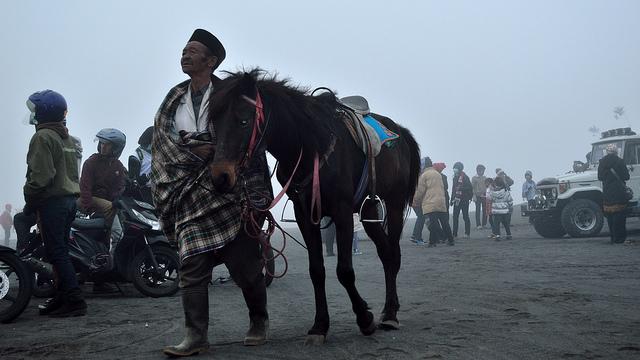Is this a calming photo?
Give a very brief answer. No. How many horses are in this picture?
Write a very short answer. 1. What is the fastest mode of transportation pictured here?
Concise answer only. Motorcycle. Is this  a color photo?
Give a very brief answer. Yes. Does this look like a place where you'd expect to find a horse?
Be succinct. No. What animal is this?
Give a very brief answer. Horse. How many horses in this photo?
Quick response, please. 1. What are the horses standing on?
Short answer required. Dirt. The plaid design is part of what?
Answer briefly. Blanket. What color is the man's hat?
Be succinct. Black. What are the men riding?
Answer briefly. Motorcycles. From the quality of the shadows, does the sky appear to be clear or overcast (or cloudy)?
Write a very short answer. Overcast. What color are the people's hats?
Write a very short answer. Black. Is the horse running?
Give a very brief answer. No. How many blue cars are in the background?
Write a very short answer. 0. What color are the lead walker's shoelaces?
Give a very brief answer. None. Is there any grass?
Give a very brief answer. No. What color is the photo?
Write a very short answer. Color. How many people ride bikes?
Short answer required. 2. What color is the taller boys shirt?
Be succinct. White. What is the main color of the horse?
Concise answer only. Black. Is there a shadow in the image?
Keep it brief. No. Is the man riding the horse?
Write a very short answer. No. What animal is on the farm?
Concise answer only. Horse. How could you see this picture better?
Short answer required. Less fog. Sunny or overcast?
Write a very short answer. Overcast. What is the man wearing?
Write a very short answer. Blanket. How many of the goats are standing?
Be succinct. 0. What type of boots is the man wearing?
Keep it brief. Cowboy. Are the horse drinking water?
Concise answer only. No. Is it cold outside?
Short answer required. Yes. What are the riders riding?
Answer briefly. Motorcycles. What does the weather look like?
Answer briefly. Foggy. Is this a real animal?
Give a very brief answer. Yes. Is this an older photo?
Give a very brief answer. No. What is the color of the horse?
Give a very brief answer. Black. What animals is in the picture?
Give a very brief answer. Horse. How many people on horses?
Answer briefly. 0. What is the animal the man is holding?
Give a very brief answer. Horse. Are these cows Holsteins?
Answer briefly. No. Where are the horses at?
Quick response, please. Beach. Is this woman an experienced equestrian?
Be succinct. Yes. Is this the desert?
Short answer required. No. What is the profession of the men in this photo?
Be succinct. Unknown. 